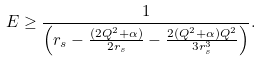<formula> <loc_0><loc_0><loc_500><loc_500>E \geq \frac { 1 } { \left ( r _ { s } - \frac { ( 2 Q ^ { 2 } + \alpha ) } { 2 r _ { s } } - \frac { 2 ( Q ^ { 2 } + \alpha ) Q ^ { 2 } } { 3 r _ { s } ^ { 3 } } \right ) } .</formula> 